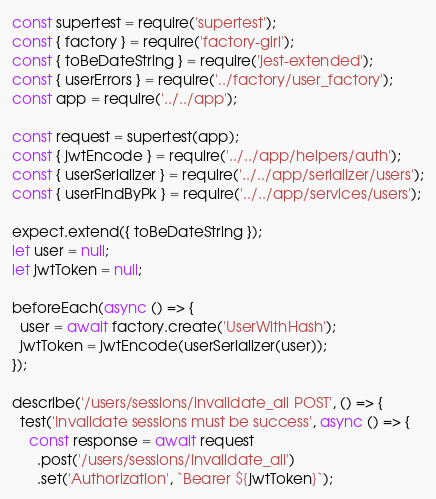<code> <loc_0><loc_0><loc_500><loc_500><_JavaScript_>const supertest = require('supertest');
const { factory } = require('factory-girl');
const { toBeDateString } = require('jest-extended');
const { userErrors } = require('../factory/user_factory');
const app = require('../../app');

const request = supertest(app);
const { jwtEncode } = require('../../app/helpers/auth');
const { userSerializer } = require('../../app/serializer/users');
const { userFindByPk } = require('../../app/services/users');

expect.extend({ toBeDateString });
let user = null;
let jwtToken = null;

beforeEach(async () => {
  user = await factory.create('UserWithHash');
  jwtToken = jwtEncode(userSerializer(user));
});

describe('/users/sessions/invalidate_all POST', () => {
  test('Invalidate sessions must be success', async () => {
    const response = await request
      .post('/users/sessions/invalidate_all')
      .set('Authorization', `Bearer ${jwtToken}`);</code> 